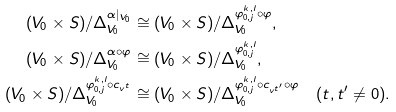<formula> <loc_0><loc_0><loc_500><loc_500>( V _ { 0 } \times S ) / \Delta _ { V _ { 0 } } ^ { \alpha | _ { V _ { 0 } } } & \cong ( V _ { 0 } \times S ) / \Delta _ { V _ { 0 } } ^ { \varphi _ { 0 , j } ^ { k , l } \circ \varphi } , \\ ( V _ { 0 } \times S ) / \Delta _ { V _ { 0 } } ^ { \alpha \circ \varphi } & \cong ( V _ { 0 } \times S ) / \Delta _ { V _ { 0 } } ^ { \varphi _ { 0 , j } ^ { k , l } } , \\ ( V _ { 0 } \times S ) / \Delta _ { V _ { 0 } } ^ { \varphi _ { 0 , j } ^ { k , l } \circ c _ { v ^ { t } } } & \cong ( V _ { 0 } \times S ) / \Delta _ { V _ { 0 } } ^ { \varphi _ { 0 , j } ^ { k , l } \circ c _ { v ^ { t ^ { \prime } } } \circ \varphi } \quad ( t , t ^ { \prime } \neq 0 ) .</formula> 